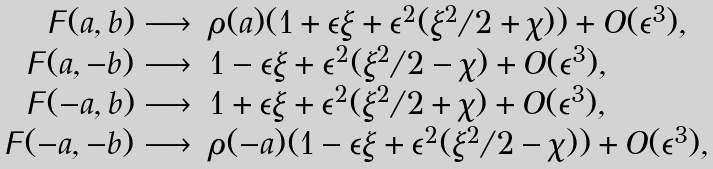<formula> <loc_0><loc_0><loc_500><loc_500>\begin{array} { r l } \digamma ( a , b ) \longrightarrow & \rho ( a ) ( 1 + \epsilon \xi + \epsilon ^ { 2 } ( \xi ^ { 2 } / 2 + \chi ) ) + O ( \epsilon ^ { 3 } ) , \\ \digamma ( a , - b ) \longrightarrow & 1 - \epsilon \xi + \epsilon ^ { 2 } ( \xi ^ { 2 } / 2 - \chi ) + O ( \epsilon ^ { 3 } ) , \\ \digamma ( - a , b ) \longrightarrow & 1 + \epsilon \xi + \epsilon ^ { 2 } ( \xi ^ { 2 } / 2 + \chi ) + O ( \epsilon ^ { 3 } ) , \\ \digamma ( - a , - b ) \longrightarrow & \rho ( - a ) ( 1 - \epsilon \xi + \epsilon ^ { 2 } ( \xi ^ { 2 } / 2 - \chi ) ) + O ( \epsilon ^ { 3 } ) , \\ \end{array}</formula> 